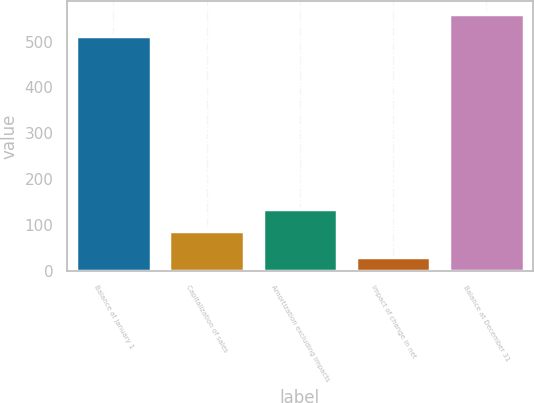<chart> <loc_0><loc_0><loc_500><loc_500><bar_chart><fcel>Balance at January 1<fcel>Capitalization of sales<fcel>Amortization excluding impacts<fcel>Impact of change in net<fcel>Balance at December 31<nl><fcel>511<fcel>87<fcel>135.6<fcel>32<fcel>559.6<nl></chart> 